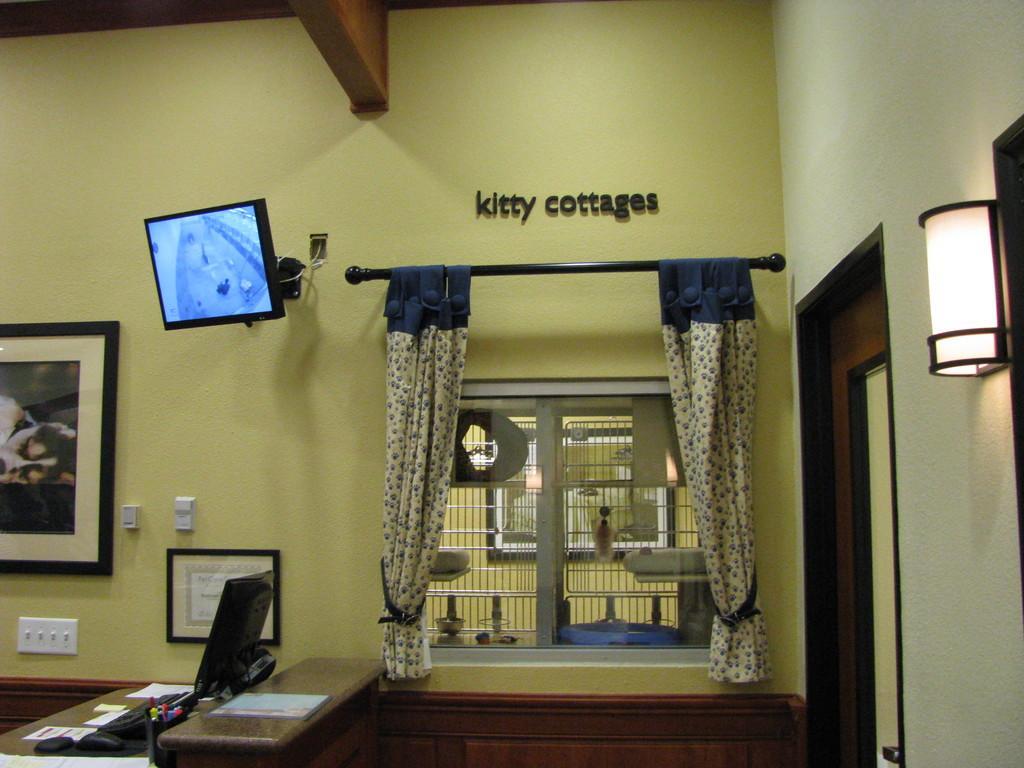Could you give a brief overview of what you see in this image? In the center of the image there is a wall, door, window, screen, monitor, platform, frames, curtains and some objects. And we can see some text on the wall. Behind the window, there is a wall with a frame and a few other objects. 